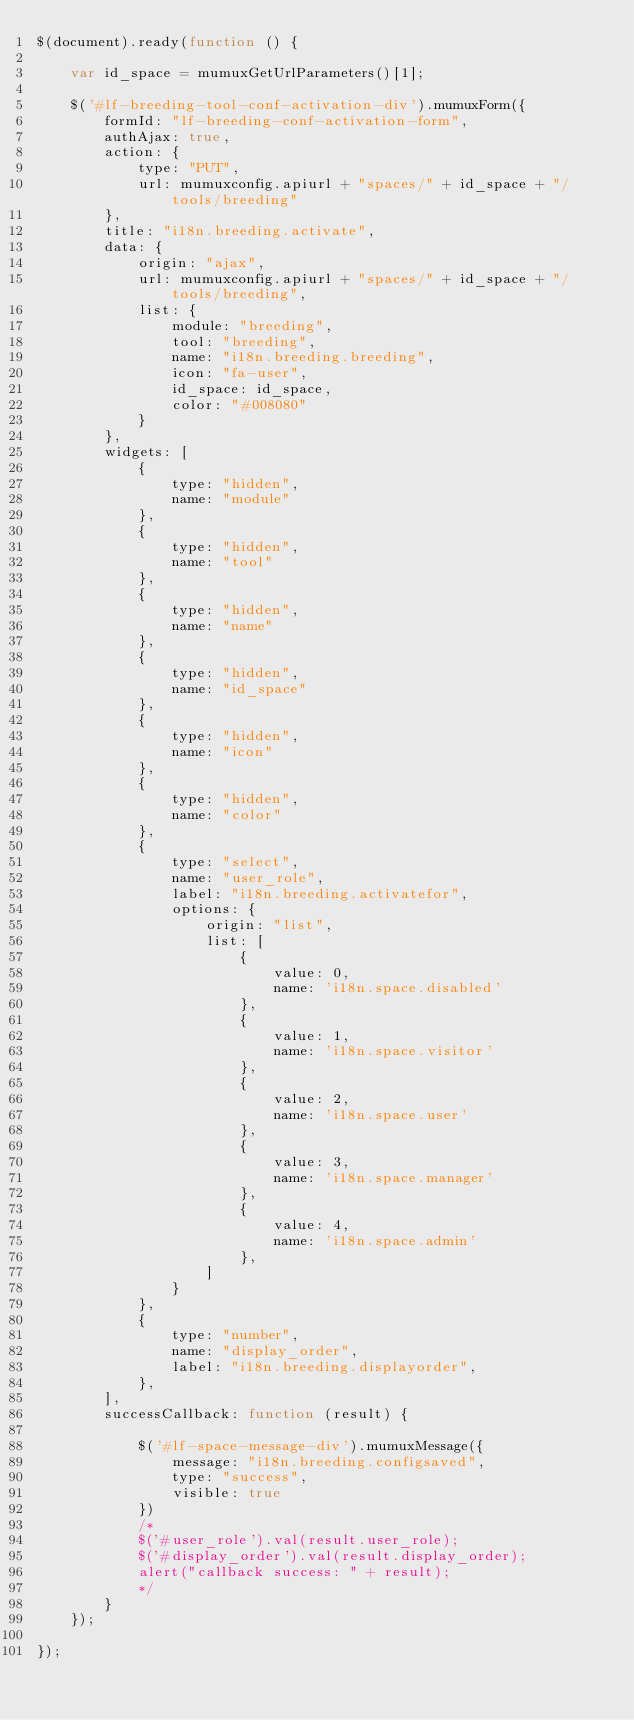Convert code to text. <code><loc_0><loc_0><loc_500><loc_500><_JavaScript_>$(document).ready(function () {

    var id_space = mumuxGetUrlParameters()[1];

    $('#lf-breeding-tool-conf-activation-div').mumuxForm({
        formId: "lf-breeding-conf-activation-form",
        authAjax: true,
        action: {
            type: "PUT",
            url: mumuxconfig.apiurl + "spaces/" + id_space + "/tools/breeding"
        },
        title: "i18n.breeding.activate",
        data: {
            origin: "ajax",
            url: mumuxconfig.apiurl + "spaces/" + id_space + "/tools/breeding",
            list: {
                module: "breeding",
                tool: "breeding",
                name: "i18n.breeding.breeding",
                icon: "fa-user",
                id_space: id_space,
                color: "#008080"
            }
        },
        widgets: [
            {
                type: "hidden",
                name: "module"
            },
            {
                type: "hidden",
                name: "tool"
            },
            {
                type: "hidden",
                name: "name"
            },
            {
                type: "hidden",
                name: "id_space"
            },
            {
                type: "hidden",
                name: "icon"
            },
            {
                type: "hidden",
                name: "color"
            },
            {
                type: "select",
                name: "user_role",
                label: "i18n.breeding.activatefor",
                options: {
                    origin: "list",
                    list: [
                        {
                            value: 0,
                            name: 'i18n.space.disabled'
                        },
                        {
                            value: 1,
                            name: 'i18n.space.visitor'
                        },
                        {
                            value: 2,
                            name: 'i18n.space.user'
                        },
                        {
                            value: 3,
                            name: 'i18n.space.manager'
                        },
                        {
                            value: 4,
                            name: 'i18n.space.admin'
                        },
                    ]
                }
            },
            {
                type: "number",
                name: "display_order",
                label: "i18n.breeding.displayorder",
            },
        ],
        successCallback: function (result) {

            $('#lf-space-message-div').mumuxMessage({
                message: "i18n.breeding.configsaved",
                type: "success",
                visible: true
            })
            /*
            $('#user_role').val(result.user_role);
            $('#display_order').val(result.display_order);
            alert("callback success: " + result);
            */
        }
    });

});</code> 